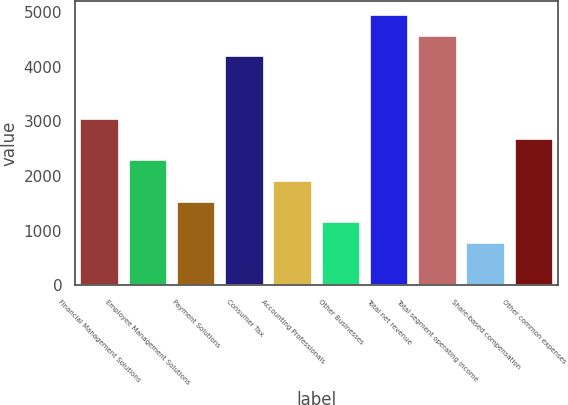Convert chart. <chart><loc_0><loc_0><loc_500><loc_500><bar_chart><fcel>Financial Management Solutions<fcel>Employee Management Solutions<fcel>Payment Solutions<fcel>Consumer Tax<fcel>Accounting Professionals<fcel>Other Businesses<fcel>Total net revenue<fcel>Total segment operating income<fcel>Share-based compensation<fcel>Other common expenses<nl><fcel>3048.4<fcel>2288.8<fcel>1529.2<fcel>4187.8<fcel>1909<fcel>1149.4<fcel>4947.4<fcel>4567.6<fcel>769.6<fcel>2668.6<nl></chart> 